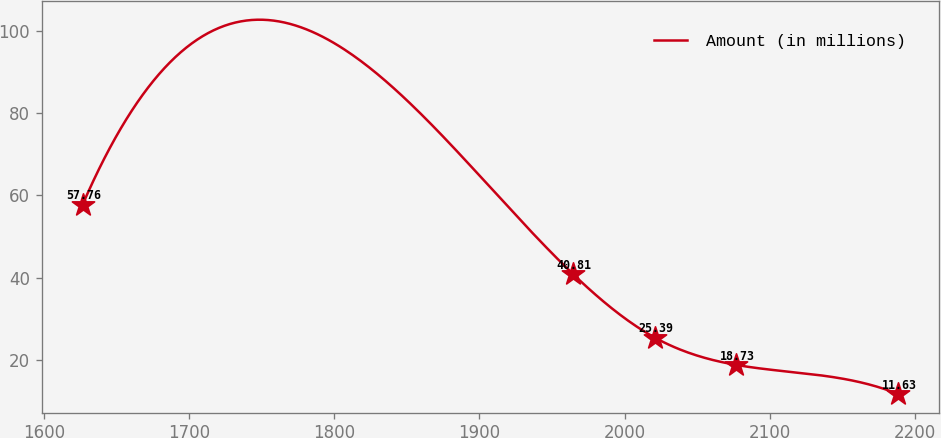Convert chart to OTSL. <chart><loc_0><loc_0><loc_500><loc_500><line_chart><ecel><fcel>Amount (in millions)<nl><fcel>1626.74<fcel>57.76<nl><fcel>1964.64<fcel>40.81<nl><fcel>2020.83<fcel>25.39<nl><fcel>2077.01<fcel>18.73<nl><fcel>2188.59<fcel>11.63<nl></chart> 